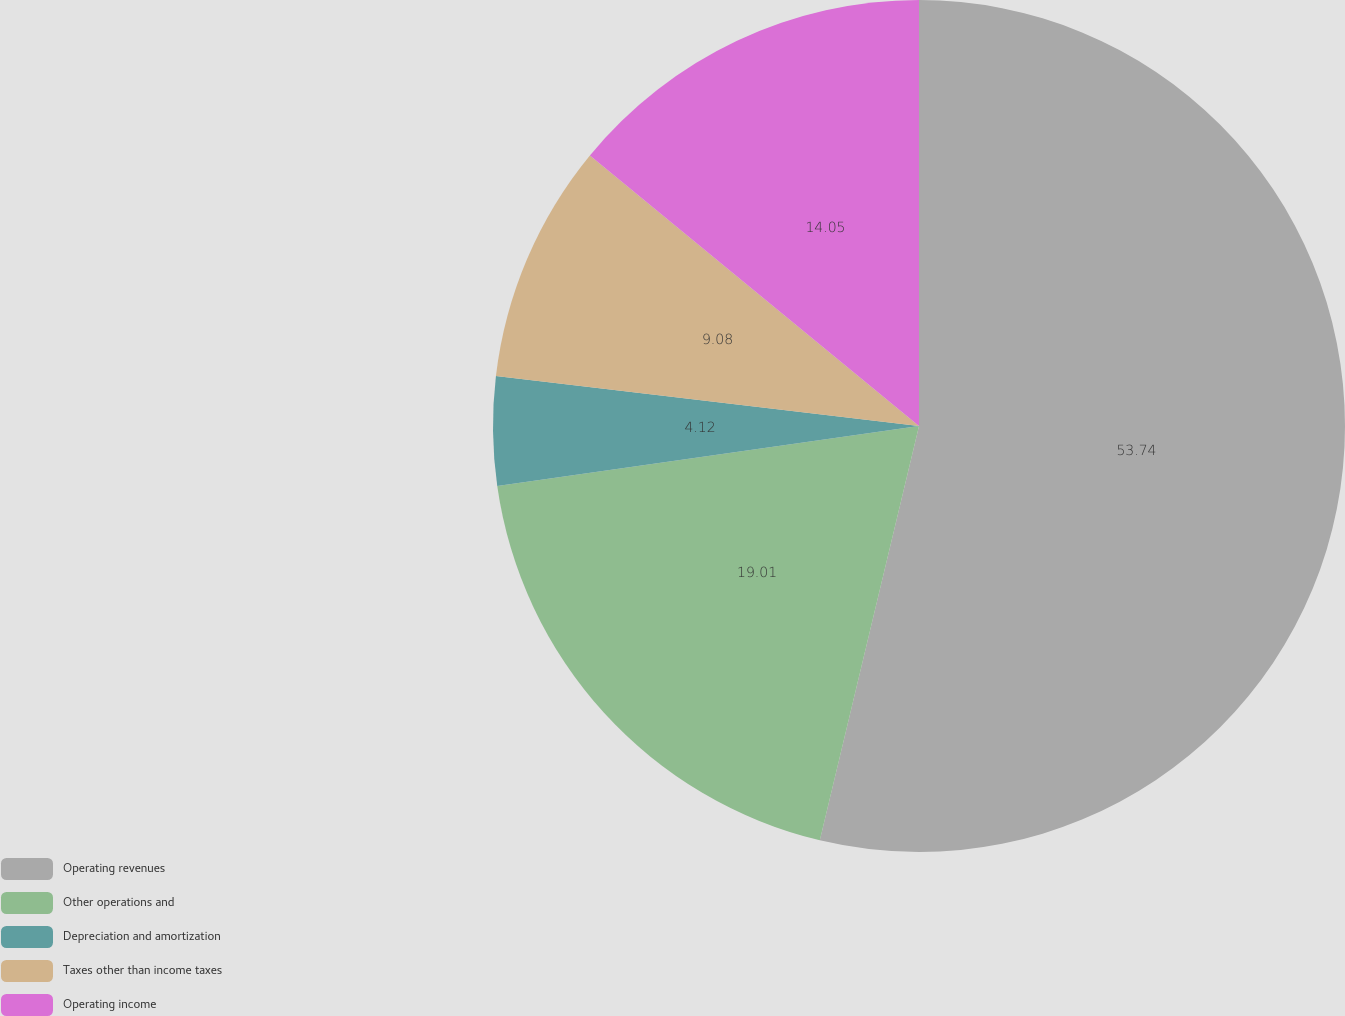<chart> <loc_0><loc_0><loc_500><loc_500><pie_chart><fcel>Operating revenues<fcel>Other operations and<fcel>Depreciation and amortization<fcel>Taxes other than income taxes<fcel>Operating income<nl><fcel>53.74%<fcel>19.01%<fcel>4.12%<fcel>9.08%<fcel>14.05%<nl></chart> 